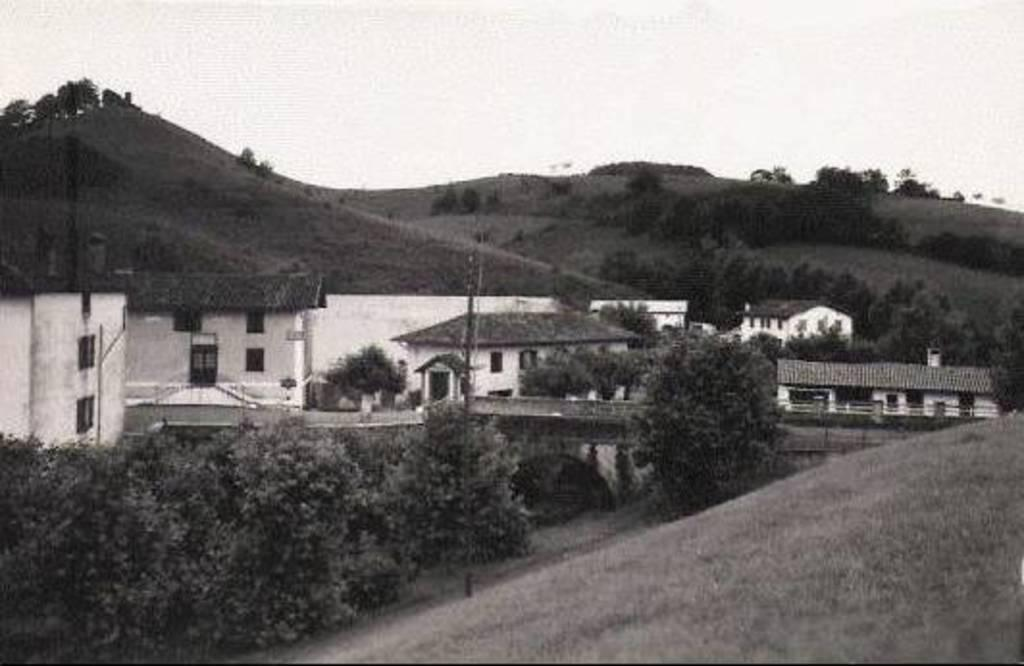What is the color scheme of the image? The image is black and white. What type of structures can be seen in the image? There are houses in the image. What other objects are present in the image? There are poles, trees, and plants in the image. What natural features can be seen in the image? There are mountains in the image. What parts of the environment are visible in the image? The ground and the sky are visible in the image. What type of harbor can be seen in the image? There is no harbor present in the image. What thoughts might the manager have while looking at the image? The image does not depict any thoughts or people, so it is impossible to determine what a manager might think while looking at it. 